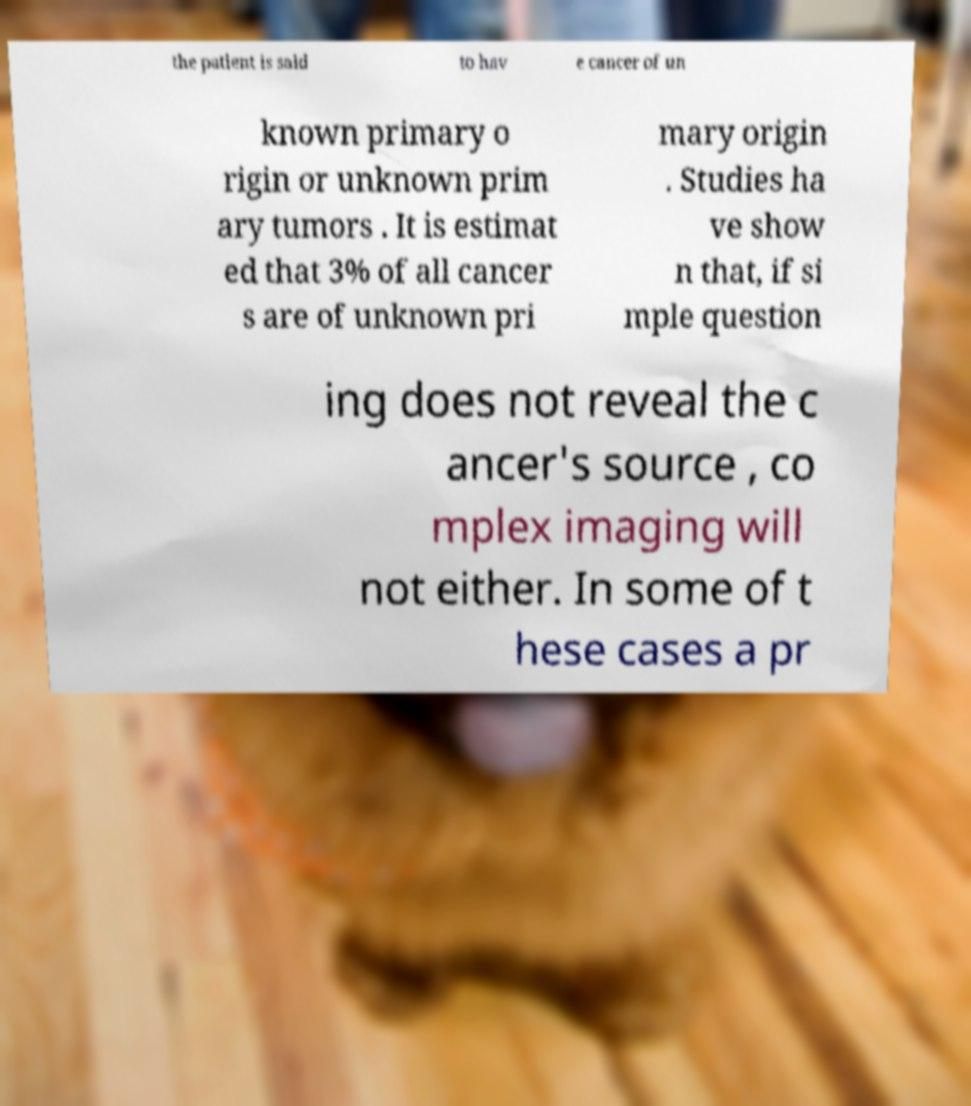I need the written content from this picture converted into text. Can you do that? the patient is said to hav e cancer of un known primary o rigin or unknown prim ary tumors . It is estimat ed that 3% of all cancer s are of unknown pri mary origin . Studies ha ve show n that, if si mple question ing does not reveal the c ancer's source , co mplex imaging will not either. In some of t hese cases a pr 